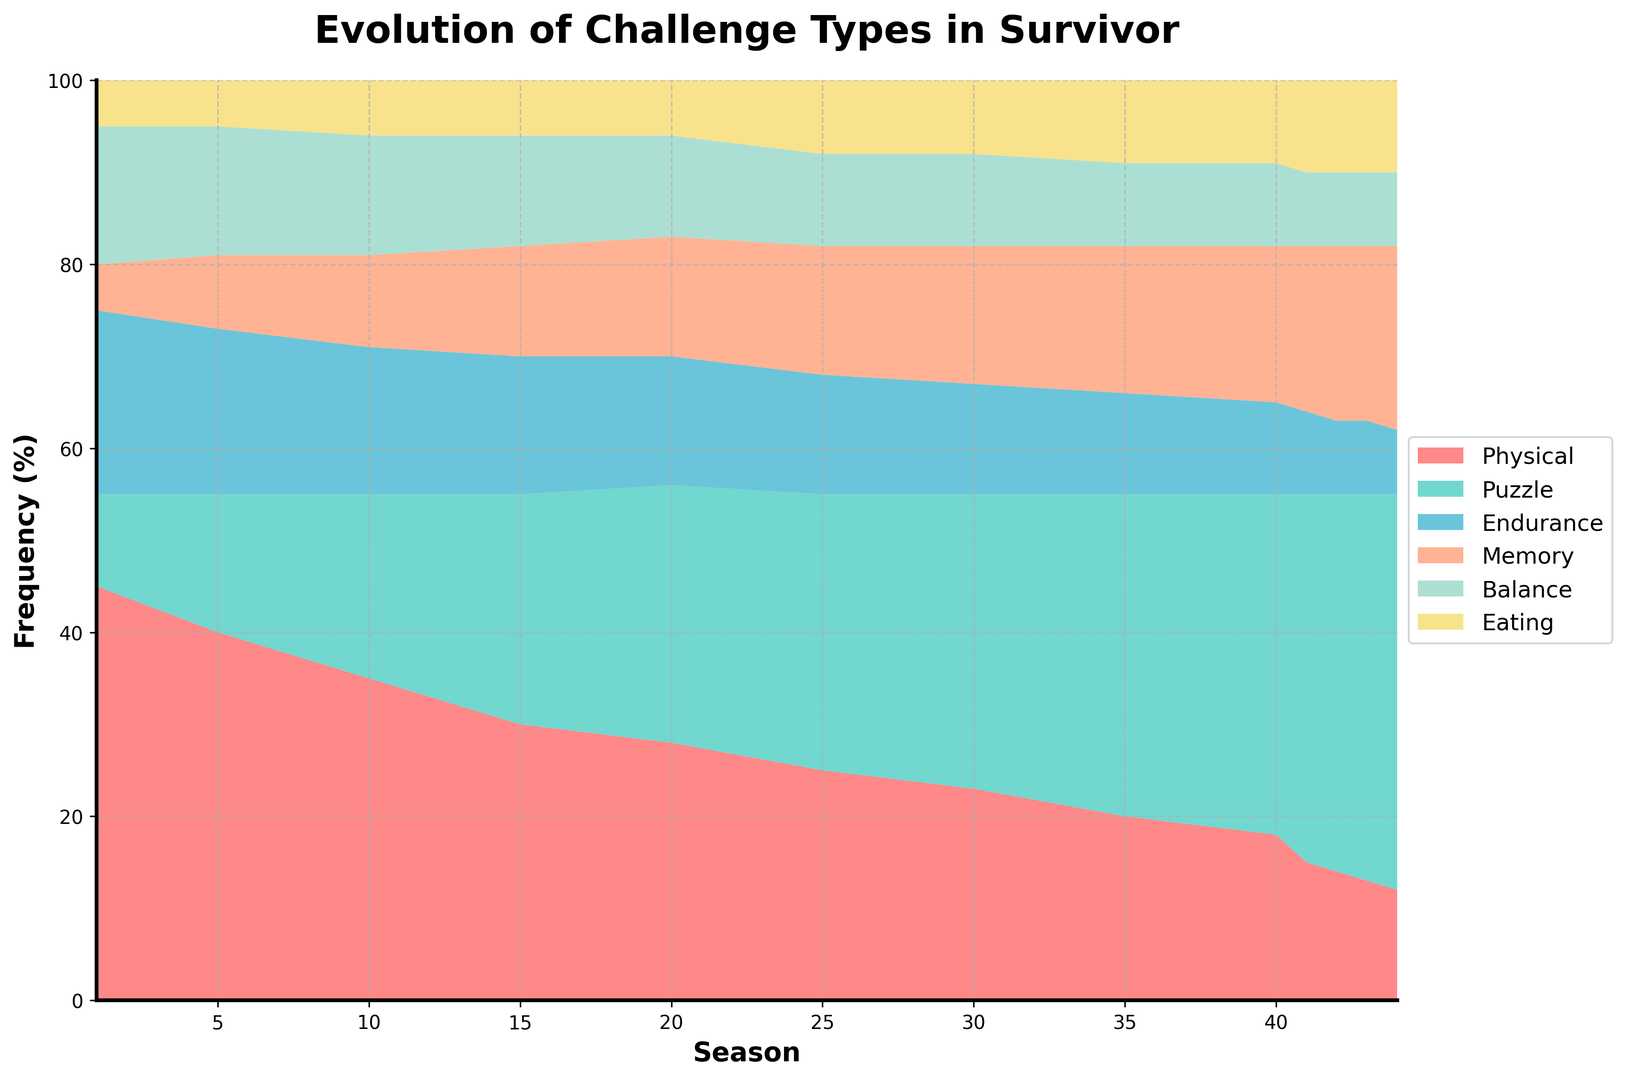What is the trend of physical challenges across the seasons? Physical challenges consistently decrease from 45% in Season 1 to 12% in Season 44.
Answer: Decreasing Which challenge type has increased the most over the seasons? The Puzzle challenge type has increased the most from 10% in Season 1 to 43% in Season 44.
Answer: Puzzle What is the total percent of Endurance challenges in seasons 30 and 35 combined? Season 30 has 12%, and Season 35 has 11%, summing them we get 12% + 11% = 23%.
Answer: 23% During which season did Memory challenges reach a higher frequency compared to Physical challenges? Memory challenges exceeded Physical challenges in Season 41 where Memory is 18% and Physical is 15%.
Answer: Season 41 How do the Eating challenges compare in frequency between Season 1 and Season 44? In Season 1, Eating challenges are at 5%, and in Season 44, they are at 10%. Eating challenges have doubled from 5% to 10%.
Answer: Doubled Between which two consecutive seasons did the percentage of Puzzle challenges increase the most? The highest increase in Puzzle challenges occurred between Season 40 (37%) and Season 41 (40%), an increase of 3%.
Answer: Season 40 and Season 41 Which challenge type has the least variation across all seasons? Eating challenges have the least variation, staying between 5% and 10% across all seasons.
Answer: Eating At which season does the Balance challenge type reach 20%? Balance challenges reach 20% in Season 44.
Answer: Season 44 